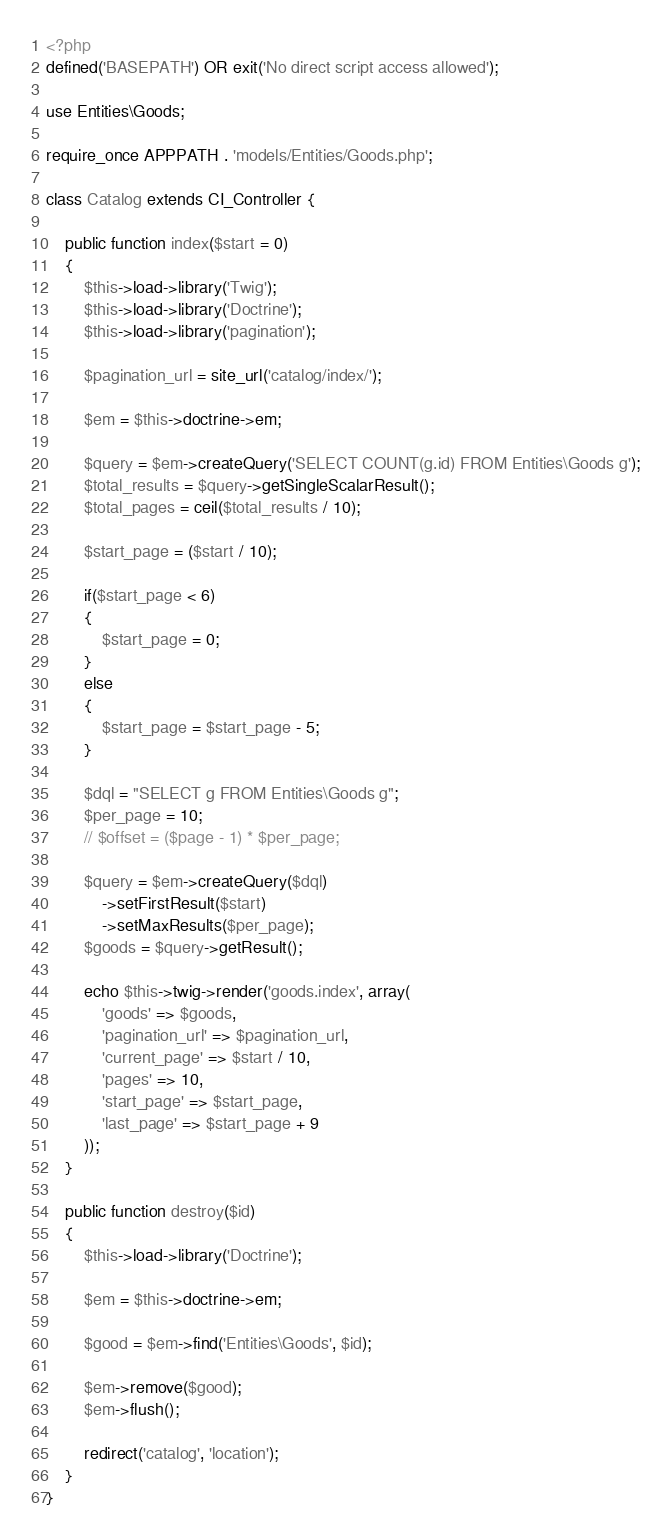Convert code to text. <code><loc_0><loc_0><loc_500><loc_500><_PHP_><?php
defined('BASEPATH') OR exit('No direct script access allowed');

use Entities\Goods;

require_once APPPATH . 'models/Entities/Goods.php';

class Catalog extends CI_Controller {

	public function index($start = 0)
	{
        $this->load->library('Twig');
        $this->load->library('Doctrine');
        $this->load->library('pagination');

        $pagination_url = site_url('catalog/index/');

        $em = $this->doctrine->em;

        $query = $em->createQuery('SELECT COUNT(g.id) FROM Entities\Goods g');
        $total_results = $query->getSingleScalarResult();
        $total_pages = ceil($total_results / 10);

        $start_page = ($start / 10);

        if($start_page < 6)
        {
            $start_page = 0;
        }
        else
        {
            $start_page = $start_page - 5;
        }

        $dql = "SELECT g FROM Entities\Goods g";
        $per_page = 10;
        // $offset = ($page - 1) * $per_page;
        
        $query = $em->createQuery($dql)
            ->setFirstResult($start)
            ->setMaxResults($per_page);
        $goods = $query->getResult();

        echo $this->twig->render('goods.index', array(
            'goods' => $goods,
            'pagination_url' => $pagination_url,
            'current_page' => $start / 10,
            'pages' => 10,
            'start_page' => $start_page,
            'last_page' => $start_page + 9
        ));
	}

    public function destroy($id)
    {
        $this->load->library('Doctrine');

        $em = $this->doctrine->em;

        $good = $em->find('Entities\Goods', $id);

        $em->remove($good);
        $em->flush();

        redirect('catalog', 'location');
    }
}
</code> 